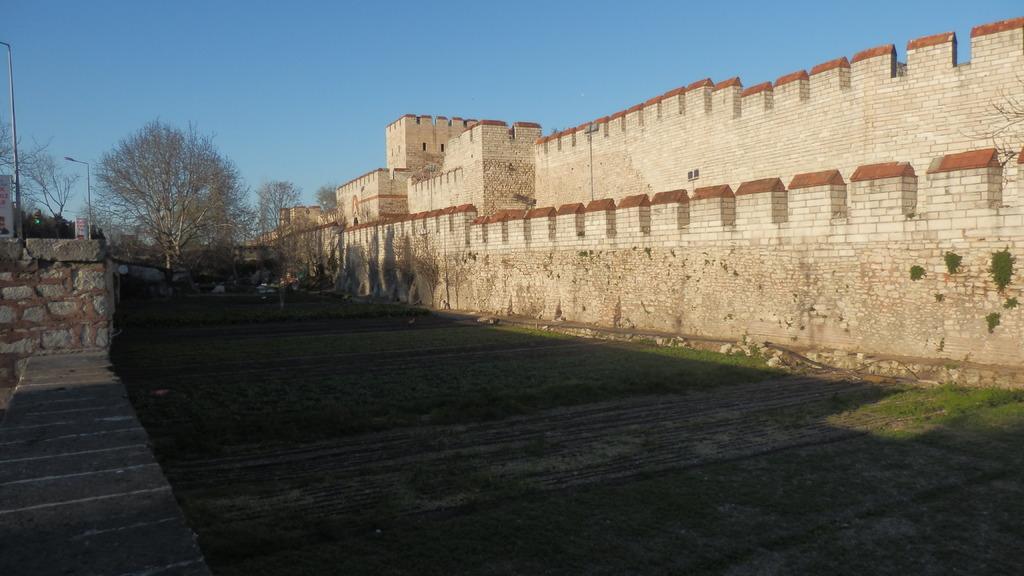Could you give a brief overview of what you see in this image? In this image on the left and right side, I can see the walls. In the middle I can see the grass and the trees. At the top I can see the sky. 